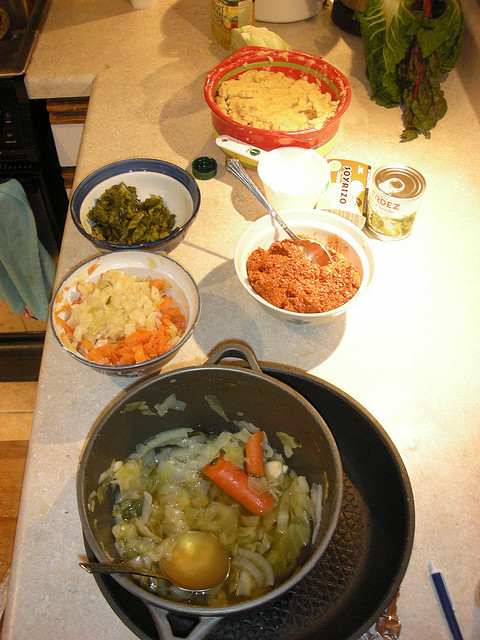<image>Are there more pink or blue packets visible in the picture? There are no packets visible in the picture. Are there more pink or blue packets visible in the picture? There are no pink or blue packets visible in the picture. 